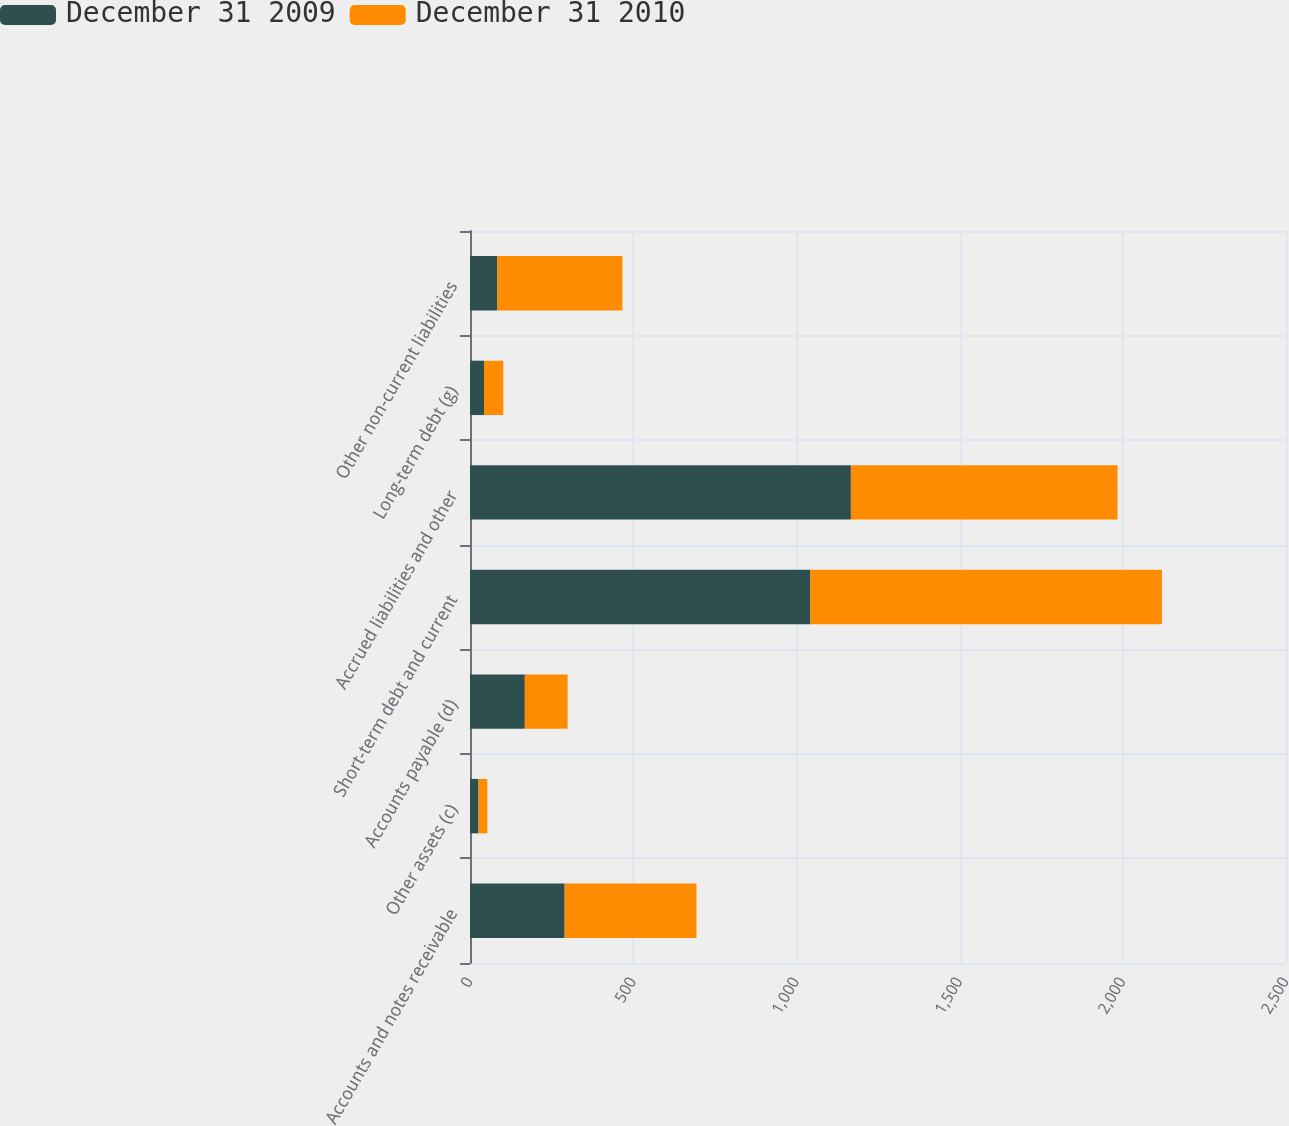<chart> <loc_0><loc_0><loc_500><loc_500><stacked_bar_chart><ecel><fcel>Accounts and notes receivable<fcel>Other assets (c)<fcel>Accounts payable (d)<fcel>Short-term debt and current<fcel>Accrued liabilities and other<fcel>Long-term debt (g)<fcel>Other non-current liabilities<nl><fcel>December 31 2009<fcel>290<fcel>26<fcel>168<fcel>1043<fcel>1167<fcel>43<fcel>84<nl><fcel>December 31 2010<fcel>404<fcel>27<fcel>131<fcel>1077<fcel>817<fcel>59<fcel>383<nl></chart> 